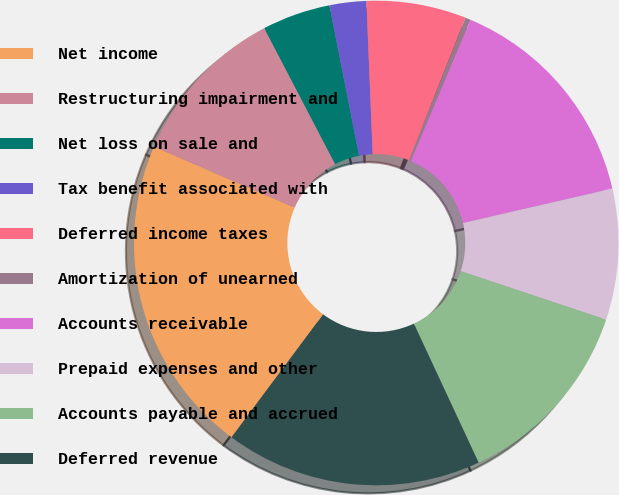<chart> <loc_0><loc_0><loc_500><loc_500><pie_chart><fcel>Net income<fcel>Restructuring impairment and<fcel>Net loss on sale and<fcel>Tax benefit associated with<fcel>Deferred income taxes<fcel>Amortization of unearned<fcel>Accounts receivable<fcel>Prepaid expenses and other<fcel>Accounts payable and accrued<fcel>Deferred revenue<nl><fcel>21.32%<fcel>10.84%<fcel>4.55%<fcel>2.45%<fcel>6.65%<fcel>0.36%<fcel>15.03%<fcel>8.74%<fcel>12.93%<fcel>17.13%<nl></chart> 